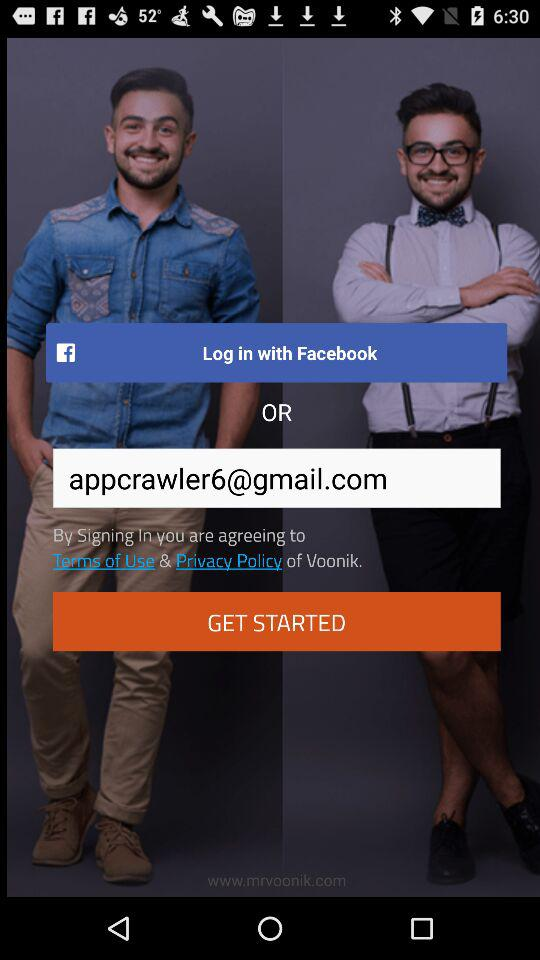What is the name of the application? The name of the application is "Voonik". 